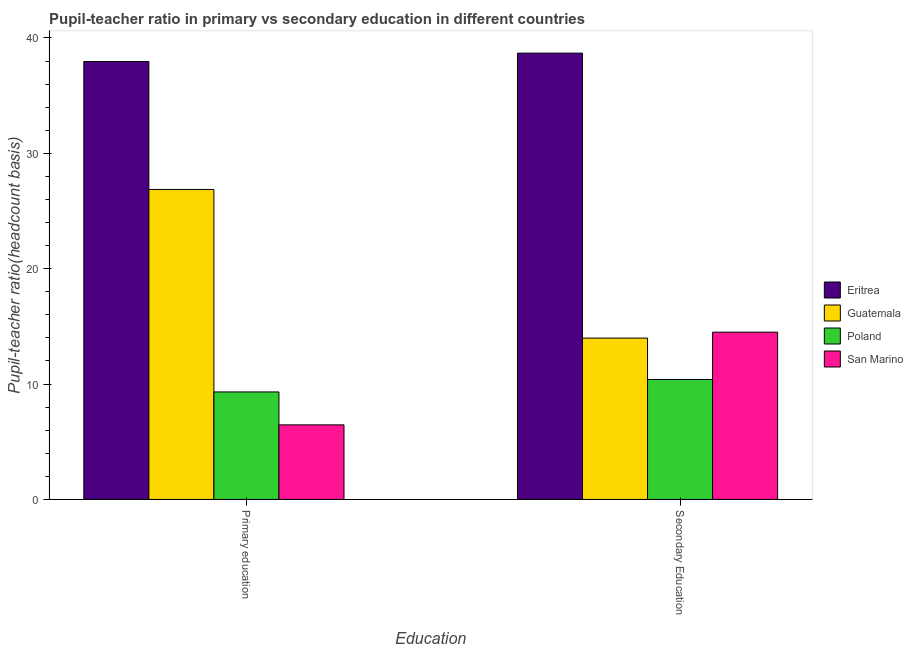Are the number of bars per tick equal to the number of legend labels?
Offer a terse response. Yes. Are the number of bars on each tick of the X-axis equal?
Your answer should be compact. Yes. How many bars are there on the 1st tick from the right?
Make the answer very short. 4. What is the label of the 1st group of bars from the left?
Give a very brief answer. Primary education. What is the pupil-teacher ratio in primary education in Poland?
Provide a short and direct response. 9.32. Across all countries, what is the maximum pupil teacher ratio on secondary education?
Keep it short and to the point. 38.68. Across all countries, what is the minimum pupil-teacher ratio in primary education?
Provide a succinct answer. 6.46. In which country was the pupil-teacher ratio in primary education maximum?
Keep it short and to the point. Eritrea. In which country was the pupil teacher ratio on secondary education minimum?
Provide a succinct answer. Poland. What is the total pupil teacher ratio on secondary education in the graph?
Make the answer very short. 77.56. What is the difference between the pupil teacher ratio on secondary education in San Marino and that in Eritrea?
Give a very brief answer. -24.19. What is the difference between the pupil teacher ratio on secondary education in Poland and the pupil-teacher ratio in primary education in San Marino?
Give a very brief answer. 3.93. What is the average pupil teacher ratio on secondary education per country?
Your response must be concise. 19.39. What is the difference between the pupil-teacher ratio in primary education and pupil teacher ratio on secondary education in Poland?
Ensure brevity in your answer.  -1.08. In how many countries, is the pupil-teacher ratio in primary education greater than 32 ?
Provide a short and direct response. 1. What is the ratio of the pupil teacher ratio on secondary education in Poland to that in San Marino?
Provide a short and direct response. 0.72. Is the pupil teacher ratio on secondary education in San Marino less than that in Eritrea?
Give a very brief answer. Yes. In how many countries, is the pupil-teacher ratio in primary education greater than the average pupil-teacher ratio in primary education taken over all countries?
Ensure brevity in your answer.  2. What does the 1st bar from the right in Secondary Education represents?
Provide a short and direct response. San Marino. How many bars are there?
Your answer should be compact. 8. How many countries are there in the graph?
Offer a very short reply. 4. What is the difference between two consecutive major ticks on the Y-axis?
Ensure brevity in your answer.  10. Does the graph contain any zero values?
Make the answer very short. No. Does the graph contain grids?
Your response must be concise. No. Where does the legend appear in the graph?
Make the answer very short. Center right. What is the title of the graph?
Keep it short and to the point. Pupil-teacher ratio in primary vs secondary education in different countries. What is the label or title of the X-axis?
Offer a very short reply. Education. What is the label or title of the Y-axis?
Your response must be concise. Pupil-teacher ratio(headcount basis). What is the Pupil-teacher ratio(headcount basis) in Eritrea in Primary education?
Your response must be concise. 37.96. What is the Pupil-teacher ratio(headcount basis) of Guatemala in Primary education?
Your answer should be very brief. 26.87. What is the Pupil-teacher ratio(headcount basis) of Poland in Primary education?
Your response must be concise. 9.32. What is the Pupil-teacher ratio(headcount basis) in San Marino in Primary education?
Your response must be concise. 6.46. What is the Pupil-teacher ratio(headcount basis) in Eritrea in Secondary Education?
Offer a very short reply. 38.68. What is the Pupil-teacher ratio(headcount basis) in Guatemala in Secondary Education?
Ensure brevity in your answer.  13.98. What is the Pupil-teacher ratio(headcount basis) in Poland in Secondary Education?
Your answer should be very brief. 10.39. What is the Pupil-teacher ratio(headcount basis) in San Marino in Secondary Education?
Your answer should be compact. 14.5. Across all Education, what is the maximum Pupil-teacher ratio(headcount basis) of Eritrea?
Make the answer very short. 38.68. Across all Education, what is the maximum Pupil-teacher ratio(headcount basis) of Guatemala?
Offer a terse response. 26.87. Across all Education, what is the maximum Pupil-teacher ratio(headcount basis) in Poland?
Your response must be concise. 10.39. Across all Education, what is the maximum Pupil-teacher ratio(headcount basis) in San Marino?
Provide a succinct answer. 14.5. Across all Education, what is the minimum Pupil-teacher ratio(headcount basis) of Eritrea?
Provide a short and direct response. 37.96. Across all Education, what is the minimum Pupil-teacher ratio(headcount basis) in Guatemala?
Make the answer very short. 13.98. Across all Education, what is the minimum Pupil-teacher ratio(headcount basis) in Poland?
Your answer should be very brief. 9.32. Across all Education, what is the minimum Pupil-teacher ratio(headcount basis) in San Marino?
Provide a succinct answer. 6.46. What is the total Pupil-teacher ratio(headcount basis) of Eritrea in the graph?
Keep it short and to the point. 76.64. What is the total Pupil-teacher ratio(headcount basis) in Guatemala in the graph?
Your answer should be compact. 40.85. What is the total Pupil-teacher ratio(headcount basis) in Poland in the graph?
Your answer should be compact. 19.71. What is the total Pupil-teacher ratio(headcount basis) in San Marino in the graph?
Make the answer very short. 20.96. What is the difference between the Pupil-teacher ratio(headcount basis) in Eritrea in Primary education and that in Secondary Education?
Offer a terse response. -0.73. What is the difference between the Pupil-teacher ratio(headcount basis) of Guatemala in Primary education and that in Secondary Education?
Your answer should be very brief. 12.88. What is the difference between the Pupil-teacher ratio(headcount basis) in Poland in Primary education and that in Secondary Education?
Your response must be concise. -1.08. What is the difference between the Pupil-teacher ratio(headcount basis) in San Marino in Primary education and that in Secondary Education?
Your answer should be very brief. -8.03. What is the difference between the Pupil-teacher ratio(headcount basis) of Eritrea in Primary education and the Pupil-teacher ratio(headcount basis) of Guatemala in Secondary Education?
Ensure brevity in your answer.  23.98. What is the difference between the Pupil-teacher ratio(headcount basis) in Eritrea in Primary education and the Pupil-teacher ratio(headcount basis) in Poland in Secondary Education?
Your response must be concise. 27.56. What is the difference between the Pupil-teacher ratio(headcount basis) of Eritrea in Primary education and the Pupil-teacher ratio(headcount basis) of San Marino in Secondary Education?
Ensure brevity in your answer.  23.46. What is the difference between the Pupil-teacher ratio(headcount basis) of Guatemala in Primary education and the Pupil-teacher ratio(headcount basis) of Poland in Secondary Education?
Your answer should be compact. 16.47. What is the difference between the Pupil-teacher ratio(headcount basis) of Guatemala in Primary education and the Pupil-teacher ratio(headcount basis) of San Marino in Secondary Education?
Offer a very short reply. 12.37. What is the difference between the Pupil-teacher ratio(headcount basis) of Poland in Primary education and the Pupil-teacher ratio(headcount basis) of San Marino in Secondary Education?
Offer a very short reply. -5.18. What is the average Pupil-teacher ratio(headcount basis) of Eritrea per Education?
Your answer should be very brief. 38.32. What is the average Pupil-teacher ratio(headcount basis) of Guatemala per Education?
Provide a succinct answer. 20.43. What is the average Pupil-teacher ratio(headcount basis) in Poland per Education?
Give a very brief answer. 9.86. What is the average Pupil-teacher ratio(headcount basis) of San Marino per Education?
Your response must be concise. 10.48. What is the difference between the Pupil-teacher ratio(headcount basis) of Eritrea and Pupil-teacher ratio(headcount basis) of Guatemala in Primary education?
Keep it short and to the point. 11.09. What is the difference between the Pupil-teacher ratio(headcount basis) of Eritrea and Pupil-teacher ratio(headcount basis) of Poland in Primary education?
Your answer should be very brief. 28.64. What is the difference between the Pupil-teacher ratio(headcount basis) in Eritrea and Pupil-teacher ratio(headcount basis) in San Marino in Primary education?
Your answer should be very brief. 31.5. What is the difference between the Pupil-teacher ratio(headcount basis) in Guatemala and Pupil-teacher ratio(headcount basis) in Poland in Primary education?
Provide a succinct answer. 17.55. What is the difference between the Pupil-teacher ratio(headcount basis) in Guatemala and Pupil-teacher ratio(headcount basis) in San Marino in Primary education?
Offer a very short reply. 20.4. What is the difference between the Pupil-teacher ratio(headcount basis) in Poland and Pupil-teacher ratio(headcount basis) in San Marino in Primary education?
Provide a succinct answer. 2.85. What is the difference between the Pupil-teacher ratio(headcount basis) of Eritrea and Pupil-teacher ratio(headcount basis) of Guatemala in Secondary Education?
Give a very brief answer. 24.7. What is the difference between the Pupil-teacher ratio(headcount basis) of Eritrea and Pupil-teacher ratio(headcount basis) of Poland in Secondary Education?
Provide a succinct answer. 28.29. What is the difference between the Pupil-teacher ratio(headcount basis) of Eritrea and Pupil-teacher ratio(headcount basis) of San Marino in Secondary Education?
Provide a succinct answer. 24.19. What is the difference between the Pupil-teacher ratio(headcount basis) in Guatemala and Pupil-teacher ratio(headcount basis) in Poland in Secondary Education?
Ensure brevity in your answer.  3.59. What is the difference between the Pupil-teacher ratio(headcount basis) in Guatemala and Pupil-teacher ratio(headcount basis) in San Marino in Secondary Education?
Make the answer very short. -0.51. What is the difference between the Pupil-teacher ratio(headcount basis) of Poland and Pupil-teacher ratio(headcount basis) of San Marino in Secondary Education?
Your answer should be very brief. -4.1. What is the ratio of the Pupil-teacher ratio(headcount basis) of Eritrea in Primary education to that in Secondary Education?
Offer a very short reply. 0.98. What is the ratio of the Pupil-teacher ratio(headcount basis) of Guatemala in Primary education to that in Secondary Education?
Make the answer very short. 1.92. What is the ratio of the Pupil-teacher ratio(headcount basis) in Poland in Primary education to that in Secondary Education?
Provide a succinct answer. 0.9. What is the ratio of the Pupil-teacher ratio(headcount basis) of San Marino in Primary education to that in Secondary Education?
Offer a terse response. 0.45. What is the difference between the highest and the second highest Pupil-teacher ratio(headcount basis) of Eritrea?
Ensure brevity in your answer.  0.73. What is the difference between the highest and the second highest Pupil-teacher ratio(headcount basis) in Guatemala?
Keep it short and to the point. 12.88. What is the difference between the highest and the second highest Pupil-teacher ratio(headcount basis) of Poland?
Keep it short and to the point. 1.08. What is the difference between the highest and the second highest Pupil-teacher ratio(headcount basis) of San Marino?
Offer a terse response. 8.03. What is the difference between the highest and the lowest Pupil-teacher ratio(headcount basis) in Eritrea?
Give a very brief answer. 0.73. What is the difference between the highest and the lowest Pupil-teacher ratio(headcount basis) of Guatemala?
Keep it short and to the point. 12.88. What is the difference between the highest and the lowest Pupil-teacher ratio(headcount basis) of Poland?
Keep it short and to the point. 1.08. What is the difference between the highest and the lowest Pupil-teacher ratio(headcount basis) in San Marino?
Provide a succinct answer. 8.03. 